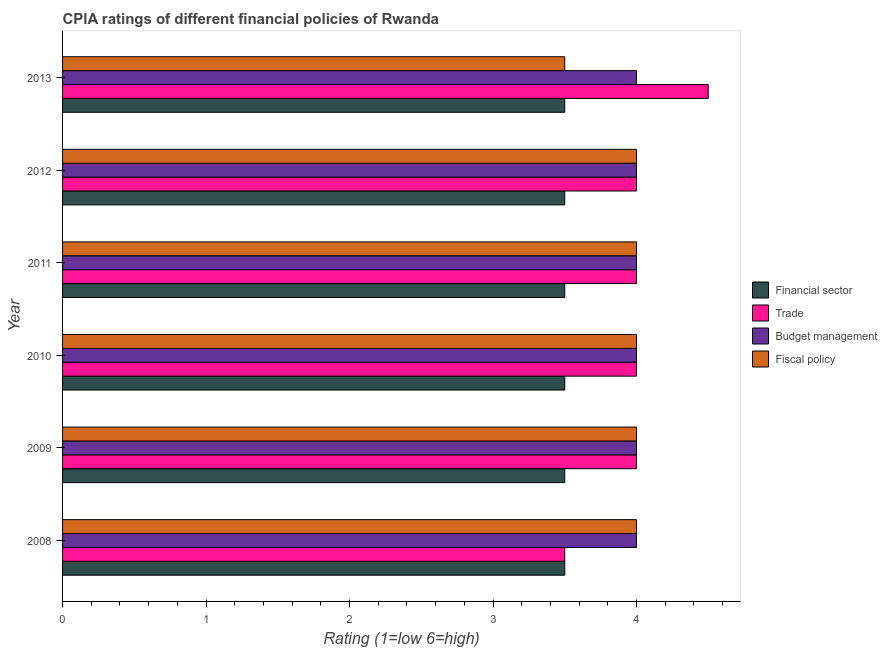How many different coloured bars are there?
Keep it short and to the point. 4. How many groups of bars are there?
Make the answer very short. 6. Are the number of bars per tick equal to the number of legend labels?
Ensure brevity in your answer.  Yes. Are the number of bars on each tick of the Y-axis equal?
Offer a terse response. Yes. How many bars are there on the 5th tick from the bottom?
Ensure brevity in your answer.  4. Across all years, what is the maximum cpia rating of fiscal policy?
Provide a short and direct response. 4. In which year was the cpia rating of financial sector maximum?
Your answer should be compact. 2008. What is the total cpia rating of fiscal policy in the graph?
Your answer should be compact. 23.5. What is the average cpia rating of fiscal policy per year?
Offer a terse response. 3.92. In the year 2009, what is the difference between the cpia rating of financial sector and cpia rating of budget management?
Provide a succinct answer. -0.5. In how many years, is the cpia rating of financial sector greater than 3.6 ?
Offer a very short reply. 0. In how many years, is the cpia rating of fiscal policy greater than the average cpia rating of fiscal policy taken over all years?
Offer a very short reply. 5. Is the sum of the cpia rating of budget management in 2009 and 2011 greater than the maximum cpia rating of fiscal policy across all years?
Offer a very short reply. Yes. Is it the case that in every year, the sum of the cpia rating of financial sector and cpia rating of trade is greater than the sum of cpia rating of budget management and cpia rating of fiscal policy?
Your response must be concise. No. What does the 4th bar from the top in 2011 represents?
Provide a short and direct response. Financial sector. What does the 4th bar from the bottom in 2013 represents?
Provide a short and direct response. Fiscal policy. How many bars are there?
Offer a very short reply. 24. What is the difference between two consecutive major ticks on the X-axis?
Keep it short and to the point. 1. Are the values on the major ticks of X-axis written in scientific E-notation?
Your answer should be compact. No. Does the graph contain grids?
Make the answer very short. No. What is the title of the graph?
Offer a very short reply. CPIA ratings of different financial policies of Rwanda. What is the label or title of the X-axis?
Keep it short and to the point. Rating (1=low 6=high). What is the Rating (1=low 6=high) of Financial sector in 2008?
Provide a succinct answer. 3.5. What is the Rating (1=low 6=high) of Trade in 2008?
Offer a terse response. 3.5. What is the Rating (1=low 6=high) of Financial sector in 2009?
Provide a succinct answer. 3.5. What is the Rating (1=low 6=high) of Trade in 2009?
Your answer should be compact. 4. What is the Rating (1=low 6=high) in Budget management in 2009?
Provide a short and direct response. 4. What is the Rating (1=low 6=high) in Fiscal policy in 2009?
Provide a short and direct response. 4. What is the Rating (1=low 6=high) of Trade in 2010?
Keep it short and to the point. 4. What is the Rating (1=low 6=high) of Budget management in 2010?
Keep it short and to the point. 4. What is the Rating (1=low 6=high) of Financial sector in 2011?
Provide a short and direct response. 3.5. What is the Rating (1=low 6=high) in Trade in 2011?
Offer a very short reply. 4. What is the Rating (1=low 6=high) in Fiscal policy in 2012?
Your answer should be compact. 4. What is the Rating (1=low 6=high) of Financial sector in 2013?
Keep it short and to the point. 3.5. What is the Rating (1=low 6=high) in Trade in 2013?
Your response must be concise. 4.5. Across all years, what is the maximum Rating (1=low 6=high) in Financial sector?
Your response must be concise. 3.5. Across all years, what is the maximum Rating (1=low 6=high) of Budget management?
Offer a very short reply. 4. Across all years, what is the maximum Rating (1=low 6=high) in Fiscal policy?
Your answer should be compact. 4. Across all years, what is the minimum Rating (1=low 6=high) of Financial sector?
Ensure brevity in your answer.  3.5. Across all years, what is the minimum Rating (1=low 6=high) in Trade?
Keep it short and to the point. 3.5. Across all years, what is the minimum Rating (1=low 6=high) in Budget management?
Offer a very short reply. 4. Across all years, what is the minimum Rating (1=low 6=high) in Fiscal policy?
Your answer should be very brief. 3.5. What is the total Rating (1=low 6=high) in Financial sector in the graph?
Make the answer very short. 21. What is the total Rating (1=low 6=high) in Trade in the graph?
Your response must be concise. 24. What is the total Rating (1=low 6=high) in Fiscal policy in the graph?
Your response must be concise. 23.5. What is the difference between the Rating (1=low 6=high) of Financial sector in 2008 and that in 2009?
Your answer should be very brief. 0. What is the difference between the Rating (1=low 6=high) in Fiscal policy in 2008 and that in 2009?
Offer a terse response. 0. What is the difference between the Rating (1=low 6=high) in Fiscal policy in 2008 and that in 2010?
Your answer should be compact. 0. What is the difference between the Rating (1=low 6=high) in Trade in 2008 and that in 2011?
Your answer should be very brief. -0.5. What is the difference between the Rating (1=low 6=high) in Financial sector in 2008 and that in 2012?
Provide a short and direct response. 0. What is the difference between the Rating (1=low 6=high) of Trade in 2008 and that in 2012?
Keep it short and to the point. -0.5. What is the difference between the Rating (1=low 6=high) of Budget management in 2008 and that in 2012?
Offer a very short reply. 0. What is the difference between the Rating (1=low 6=high) of Fiscal policy in 2008 and that in 2012?
Ensure brevity in your answer.  0. What is the difference between the Rating (1=low 6=high) of Trade in 2008 and that in 2013?
Keep it short and to the point. -1. What is the difference between the Rating (1=low 6=high) in Budget management in 2008 and that in 2013?
Make the answer very short. 0. What is the difference between the Rating (1=low 6=high) in Fiscal policy in 2008 and that in 2013?
Give a very brief answer. 0.5. What is the difference between the Rating (1=low 6=high) of Trade in 2009 and that in 2010?
Offer a very short reply. 0. What is the difference between the Rating (1=low 6=high) of Fiscal policy in 2009 and that in 2010?
Offer a terse response. 0. What is the difference between the Rating (1=low 6=high) in Financial sector in 2009 and that in 2011?
Give a very brief answer. 0. What is the difference between the Rating (1=low 6=high) in Budget management in 2009 and that in 2011?
Keep it short and to the point. 0. What is the difference between the Rating (1=low 6=high) of Fiscal policy in 2009 and that in 2011?
Your answer should be compact. 0. What is the difference between the Rating (1=low 6=high) in Budget management in 2009 and that in 2012?
Provide a short and direct response. 0. What is the difference between the Rating (1=low 6=high) of Financial sector in 2009 and that in 2013?
Ensure brevity in your answer.  0. What is the difference between the Rating (1=low 6=high) of Fiscal policy in 2009 and that in 2013?
Make the answer very short. 0.5. What is the difference between the Rating (1=low 6=high) of Financial sector in 2010 and that in 2011?
Your response must be concise. 0. What is the difference between the Rating (1=low 6=high) of Trade in 2010 and that in 2011?
Keep it short and to the point. 0. What is the difference between the Rating (1=low 6=high) in Budget management in 2010 and that in 2011?
Offer a terse response. 0. What is the difference between the Rating (1=low 6=high) of Fiscal policy in 2010 and that in 2011?
Your response must be concise. 0. What is the difference between the Rating (1=low 6=high) of Financial sector in 2010 and that in 2012?
Provide a succinct answer. 0. What is the difference between the Rating (1=low 6=high) of Trade in 2010 and that in 2012?
Provide a short and direct response. 0. What is the difference between the Rating (1=low 6=high) in Budget management in 2010 and that in 2012?
Provide a short and direct response. 0. What is the difference between the Rating (1=low 6=high) of Fiscal policy in 2010 and that in 2012?
Keep it short and to the point. 0. What is the difference between the Rating (1=low 6=high) in Trade in 2010 and that in 2013?
Keep it short and to the point. -0.5. What is the difference between the Rating (1=low 6=high) in Budget management in 2010 and that in 2013?
Offer a terse response. 0. What is the difference between the Rating (1=low 6=high) in Fiscal policy in 2010 and that in 2013?
Keep it short and to the point. 0.5. What is the difference between the Rating (1=low 6=high) of Trade in 2011 and that in 2012?
Offer a terse response. 0. What is the difference between the Rating (1=low 6=high) in Budget management in 2011 and that in 2012?
Your response must be concise. 0. What is the difference between the Rating (1=low 6=high) in Fiscal policy in 2011 and that in 2012?
Provide a succinct answer. 0. What is the difference between the Rating (1=low 6=high) of Financial sector in 2011 and that in 2013?
Offer a very short reply. 0. What is the difference between the Rating (1=low 6=high) in Budget management in 2011 and that in 2013?
Ensure brevity in your answer.  0. What is the difference between the Rating (1=low 6=high) of Fiscal policy in 2011 and that in 2013?
Make the answer very short. 0.5. What is the difference between the Rating (1=low 6=high) in Financial sector in 2012 and that in 2013?
Ensure brevity in your answer.  0. What is the difference between the Rating (1=low 6=high) in Financial sector in 2008 and the Rating (1=low 6=high) in Trade in 2009?
Your response must be concise. -0.5. What is the difference between the Rating (1=low 6=high) of Trade in 2008 and the Rating (1=low 6=high) of Budget management in 2009?
Give a very brief answer. -0.5. What is the difference between the Rating (1=low 6=high) in Trade in 2008 and the Rating (1=low 6=high) in Fiscal policy in 2009?
Your answer should be very brief. -0.5. What is the difference between the Rating (1=low 6=high) in Budget management in 2008 and the Rating (1=low 6=high) in Fiscal policy in 2009?
Keep it short and to the point. 0. What is the difference between the Rating (1=low 6=high) of Trade in 2008 and the Rating (1=low 6=high) of Budget management in 2010?
Offer a very short reply. -0.5. What is the difference between the Rating (1=low 6=high) in Trade in 2008 and the Rating (1=low 6=high) in Fiscal policy in 2010?
Make the answer very short. -0.5. What is the difference between the Rating (1=low 6=high) in Financial sector in 2008 and the Rating (1=low 6=high) in Trade in 2011?
Offer a terse response. -0.5. What is the difference between the Rating (1=low 6=high) of Financial sector in 2008 and the Rating (1=low 6=high) of Budget management in 2011?
Offer a terse response. -0.5. What is the difference between the Rating (1=low 6=high) of Financial sector in 2008 and the Rating (1=low 6=high) of Fiscal policy in 2011?
Keep it short and to the point. -0.5. What is the difference between the Rating (1=low 6=high) in Financial sector in 2008 and the Rating (1=low 6=high) in Budget management in 2012?
Provide a succinct answer. -0.5. What is the difference between the Rating (1=low 6=high) in Trade in 2008 and the Rating (1=low 6=high) in Fiscal policy in 2012?
Give a very brief answer. -0.5. What is the difference between the Rating (1=low 6=high) of Budget management in 2008 and the Rating (1=low 6=high) of Fiscal policy in 2012?
Your response must be concise. 0. What is the difference between the Rating (1=low 6=high) of Financial sector in 2008 and the Rating (1=low 6=high) of Trade in 2013?
Provide a succinct answer. -1. What is the difference between the Rating (1=low 6=high) of Financial sector in 2008 and the Rating (1=low 6=high) of Budget management in 2013?
Provide a succinct answer. -0.5. What is the difference between the Rating (1=low 6=high) in Financial sector in 2008 and the Rating (1=low 6=high) in Fiscal policy in 2013?
Ensure brevity in your answer.  0. What is the difference between the Rating (1=low 6=high) of Trade in 2008 and the Rating (1=low 6=high) of Fiscal policy in 2013?
Ensure brevity in your answer.  0. What is the difference between the Rating (1=low 6=high) in Budget management in 2008 and the Rating (1=low 6=high) in Fiscal policy in 2013?
Ensure brevity in your answer.  0.5. What is the difference between the Rating (1=low 6=high) of Financial sector in 2009 and the Rating (1=low 6=high) of Trade in 2010?
Your answer should be very brief. -0.5. What is the difference between the Rating (1=low 6=high) of Financial sector in 2009 and the Rating (1=low 6=high) of Budget management in 2010?
Offer a terse response. -0.5. What is the difference between the Rating (1=low 6=high) of Trade in 2009 and the Rating (1=low 6=high) of Budget management in 2010?
Offer a very short reply. 0. What is the difference between the Rating (1=low 6=high) of Trade in 2009 and the Rating (1=low 6=high) of Budget management in 2011?
Your answer should be very brief. 0. What is the difference between the Rating (1=low 6=high) of Financial sector in 2009 and the Rating (1=low 6=high) of Fiscal policy in 2012?
Provide a short and direct response. -0.5. What is the difference between the Rating (1=low 6=high) in Trade in 2009 and the Rating (1=low 6=high) in Budget management in 2012?
Make the answer very short. 0. What is the difference between the Rating (1=low 6=high) of Trade in 2009 and the Rating (1=low 6=high) of Fiscal policy in 2012?
Provide a succinct answer. 0. What is the difference between the Rating (1=low 6=high) of Financial sector in 2009 and the Rating (1=low 6=high) of Trade in 2013?
Make the answer very short. -1. What is the difference between the Rating (1=low 6=high) of Trade in 2009 and the Rating (1=low 6=high) of Budget management in 2013?
Ensure brevity in your answer.  0. What is the difference between the Rating (1=low 6=high) of Budget management in 2009 and the Rating (1=low 6=high) of Fiscal policy in 2013?
Offer a very short reply. 0.5. What is the difference between the Rating (1=low 6=high) of Trade in 2010 and the Rating (1=low 6=high) of Budget management in 2011?
Offer a very short reply. 0. What is the difference between the Rating (1=low 6=high) in Trade in 2010 and the Rating (1=low 6=high) in Fiscal policy in 2011?
Your response must be concise. 0. What is the difference between the Rating (1=low 6=high) of Budget management in 2010 and the Rating (1=low 6=high) of Fiscal policy in 2012?
Offer a very short reply. 0. What is the difference between the Rating (1=low 6=high) in Financial sector in 2010 and the Rating (1=low 6=high) in Budget management in 2013?
Your answer should be compact. -0.5. What is the difference between the Rating (1=low 6=high) in Budget management in 2010 and the Rating (1=low 6=high) in Fiscal policy in 2013?
Provide a short and direct response. 0.5. What is the difference between the Rating (1=low 6=high) in Financial sector in 2011 and the Rating (1=low 6=high) in Trade in 2012?
Keep it short and to the point. -0.5. What is the difference between the Rating (1=low 6=high) in Financial sector in 2011 and the Rating (1=low 6=high) in Budget management in 2012?
Your response must be concise. -0.5. What is the difference between the Rating (1=low 6=high) of Financial sector in 2011 and the Rating (1=low 6=high) of Trade in 2013?
Provide a succinct answer. -1. What is the difference between the Rating (1=low 6=high) in Trade in 2011 and the Rating (1=low 6=high) in Budget management in 2013?
Your response must be concise. 0. What is the difference between the Rating (1=low 6=high) in Budget management in 2011 and the Rating (1=low 6=high) in Fiscal policy in 2013?
Provide a short and direct response. 0.5. What is the difference between the Rating (1=low 6=high) of Financial sector in 2012 and the Rating (1=low 6=high) of Budget management in 2013?
Ensure brevity in your answer.  -0.5. What is the difference between the Rating (1=low 6=high) of Financial sector in 2012 and the Rating (1=low 6=high) of Fiscal policy in 2013?
Give a very brief answer. 0. What is the difference between the Rating (1=low 6=high) in Trade in 2012 and the Rating (1=low 6=high) in Budget management in 2013?
Offer a very short reply. 0. What is the average Rating (1=low 6=high) of Budget management per year?
Your answer should be compact. 4. What is the average Rating (1=low 6=high) of Fiscal policy per year?
Your answer should be compact. 3.92. In the year 2008, what is the difference between the Rating (1=low 6=high) in Financial sector and Rating (1=low 6=high) in Trade?
Make the answer very short. 0. In the year 2008, what is the difference between the Rating (1=low 6=high) in Financial sector and Rating (1=low 6=high) in Fiscal policy?
Provide a short and direct response. -0.5. In the year 2009, what is the difference between the Rating (1=low 6=high) of Financial sector and Rating (1=low 6=high) of Trade?
Your answer should be compact. -0.5. In the year 2009, what is the difference between the Rating (1=low 6=high) in Trade and Rating (1=low 6=high) in Budget management?
Your response must be concise. 0. In the year 2010, what is the difference between the Rating (1=low 6=high) of Financial sector and Rating (1=low 6=high) of Trade?
Your answer should be very brief. -0.5. In the year 2010, what is the difference between the Rating (1=low 6=high) in Financial sector and Rating (1=low 6=high) in Fiscal policy?
Make the answer very short. -0.5. In the year 2010, what is the difference between the Rating (1=low 6=high) in Trade and Rating (1=low 6=high) in Budget management?
Offer a very short reply. 0. In the year 2010, what is the difference between the Rating (1=low 6=high) in Budget management and Rating (1=low 6=high) in Fiscal policy?
Offer a very short reply. 0. In the year 2011, what is the difference between the Rating (1=low 6=high) of Financial sector and Rating (1=low 6=high) of Trade?
Your answer should be very brief. -0.5. In the year 2011, what is the difference between the Rating (1=low 6=high) of Financial sector and Rating (1=low 6=high) of Fiscal policy?
Your answer should be very brief. -0.5. In the year 2011, what is the difference between the Rating (1=low 6=high) in Trade and Rating (1=low 6=high) in Budget management?
Offer a very short reply. 0. In the year 2011, what is the difference between the Rating (1=low 6=high) in Trade and Rating (1=low 6=high) in Fiscal policy?
Provide a succinct answer. 0. In the year 2011, what is the difference between the Rating (1=low 6=high) in Budget management and Rating (1=low 6=high) in Fiscal policy?
Provide a short and direct response. 0. In the year 2012, what is the difference between the Rating (1=low 6=high) in Financial sector and Rating (1=low 6=high) in Trade?
Offer a very short reply. -0.5. In the year 2012, what is the difference between the Rating (1=low 6=high) in Financial sector and Rating (1=low 6=high) in Budget management?
Offer a very short reply. -0.5. In the year 2012, what is the difference between the Rating (1=low 6=high) in Financial sector and Rating (1=low 6=high) in Fiscal policy?
Ensure brevity in your answer.  -0.5. In the year 2012, what is the difference between the Rating (1=low 6=high) in Trade and Rating (1=low 6=high) in Budget management?
Your answer should be very brief. 0. In the year 2012, what is the difference between the Rating (1=low 6=high) of Trade and Rating (1=low 6=high) of Fiscal policy?
Ensure brevity in your answer.  0. In the year 2013, what is the difference between the Rating (1=low 6=high) in Financial sector and Rating (1=low 6=high) in Fiscal policy?
Provide a succinct answer. 0. In the year 2013, what is the difference between the Rating (1=low 6=high) of Trade and Rating (1=low 6=high) of Budget management?
Offer a terse response. 0.5. In the year 2013, what is the difference between the Rating (1=low 6=high) of Budget management and Rating (1=low 6=high) of Fiscal policy?
Ensure brevity in your answer.  0.5. What is the ratio of the Rating (1=low 6=high) in Financial sector in 2008 to that in 2009?
Ensure brevity in your answer.  1. What is the ratio of the Rating (1=low 6=high) of Trade in 2008 to that in 2010?
Your response must be concise. 0.88. What is the ratio of the Rating (1=low 6=high) of Budget management in 2008 to that in 2010?
Provide a short and direct response. 1. What is the ratio of the Rating (1=low 6=high) in Fiscal policy in 2008 to that in 2010?
Your response must be concise. 1. What is the ratio of the Rating (1=low 6=high) in Financial sector in 2008 to that in 2011?
Ensure brevity in your answer.  1. What is the ratio of the Rating (1=low 6=high) of Budget management in 2008 to that in 2011?
Provide a short and direct response. 1. What is the ratio of the Rating (1=low 6=high) in Fiscal policy in 2008 to that in 2012?
Your answer should be very brief. 1. What is the ratio of the Rating (1=low 6=high) of Financial sector in 2009 to that in 2010?
Give a very brief answer. 1. What is the ratio of the Rating (1=low 6=high) of Fiscal policy in 2009 to that in 2010?
Your response must be concise. 1. What is the ratio of the Rating (1=low 6=high) in Trade in 2009 to that in 2011?
Offer a terse response. 1. What is the ratio of the Rating (1=low 6=high) of Budget management in 2009 to that in 2011?
Provide a short and direct response. 1. What is the ratio of the Rating (1=low 6=high) in Trade in 2009 to that in 2012?
Provide a short and direct response. 1. What is the ratio of the Rating (1=low 6=high) in Fiscal policy in 2009 to that in 2012?
Your answer should be compact. 1. What is the ratio of the Rating (1=low 6=high) of Financial sector in 2009 to that in 2013?
Ensure brevity in your answer.  1. What is the ratio of the Rating (1=low 6=high) of Trade in 2010 to that in 2012?
Offer a terse response. 1. What is the ratio of the Rating (1=low 6=high) in Budget management in 2010 to that in 2012?
Your response must be concise. 1. What is the ratio of the Rating (1=low 6=high) of Fiscal policy in 2010 to that in 2012?
Your answer should be compact. 1. What is the ratio of the Rating (1=low 6=high) in Financial sector in 2010 to that in 2013?
Provide a short and direct response. 1. What is the ratio of the Rating (1=low 6=high) in Trade in 2010 to that in 2013?
Give a very brief answer. 0.89. What is the ratio of the Rating (1=low 6=high) of Budget management in 2010 to that in 2013?
Your answer should be compact. 1. What is the ratio of the Rating (1=low 6=high) of Fiscal policy in 2010 to that in 2013?
Give a very brief answer. 1.14. What is the ratio of the Rating (1=low 6=high) of Financial sector in 2011 to that in 2013?
Your answer should be compact. 1. What is the ratio of the Rating (1=low 6=high) in Fiscal policy in 2011 to that in 2013?
Your response must be concise. 1.14. What is the ratio of the Rating (1=low 6=high) in Trade in 2012 to that in 2013?
Make the answer very short. 0.89. What is the ratio of the Rating (1=low 6=high) in Fiscal policy in 2012 to that in 2013?
Your answer should be very brief. 1.14. What is the difference between the highest and the second highest Rating (1=low 6=high) in Trade?
Give a very brief answer. 0.5. What is the difference between the highest and the lowest Rating (1=low 6=high) in Financial sector?
Offer a terse response. 0. What is the difference between the highest and the lowest Rating (1=low 6=high) in Trade?
Keep it short and to the point. 1. 